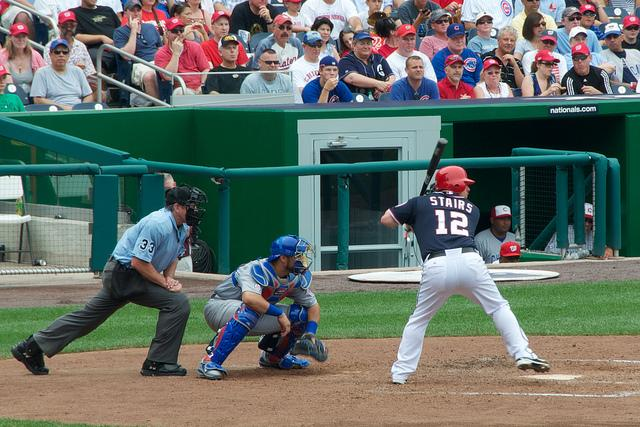What team does the catcher play for? chicago cubs 